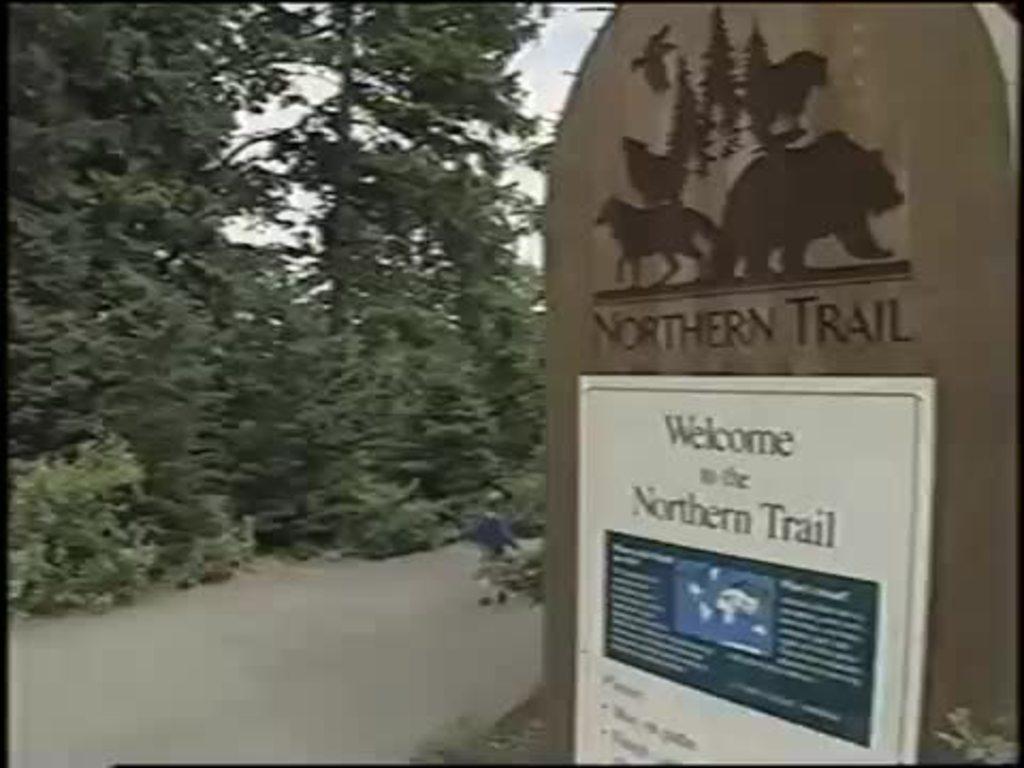Is this trail outside?
Make the answer very short. Yes. 